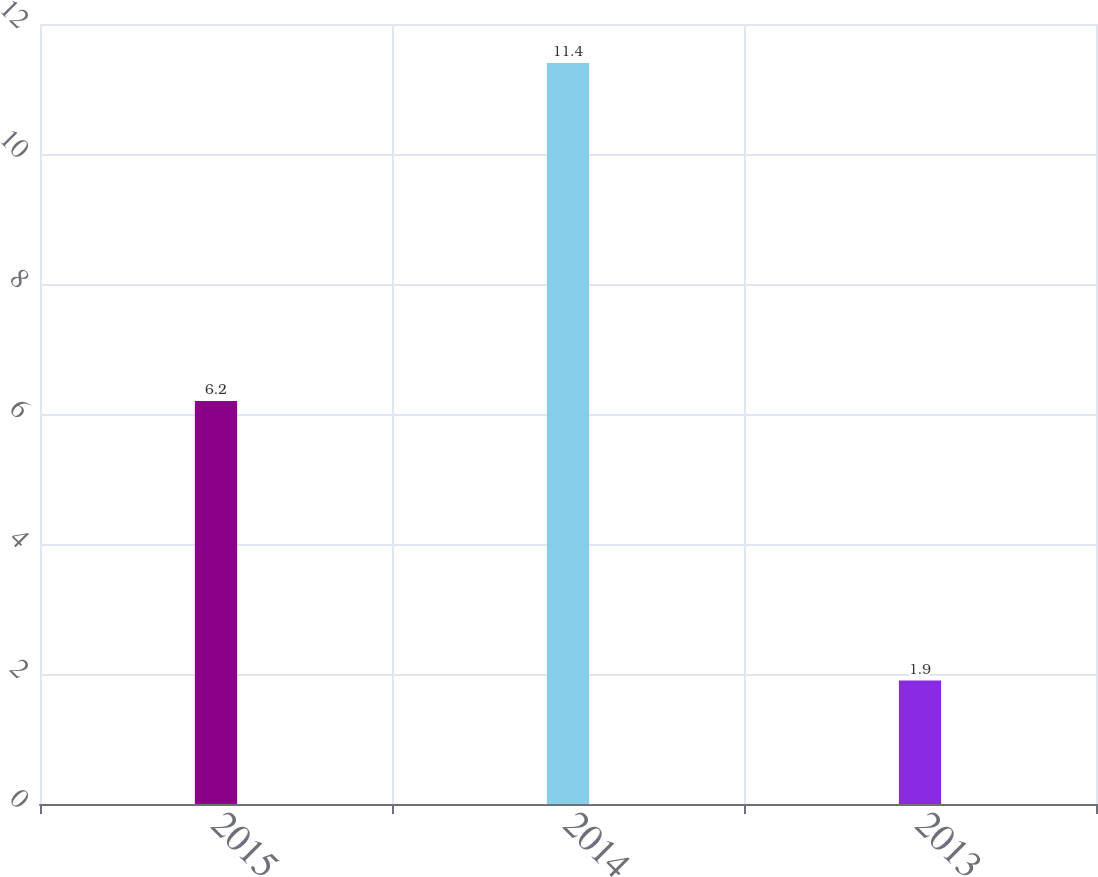Convert chart. <chart><loc_0><loc_0><loc_500><loc_500><bar_chart><fcel>2015<fcel>2014<fcel>2013<nl><fcel>6.2<fcel>11.4<fcel>1.9<nl></chart> 